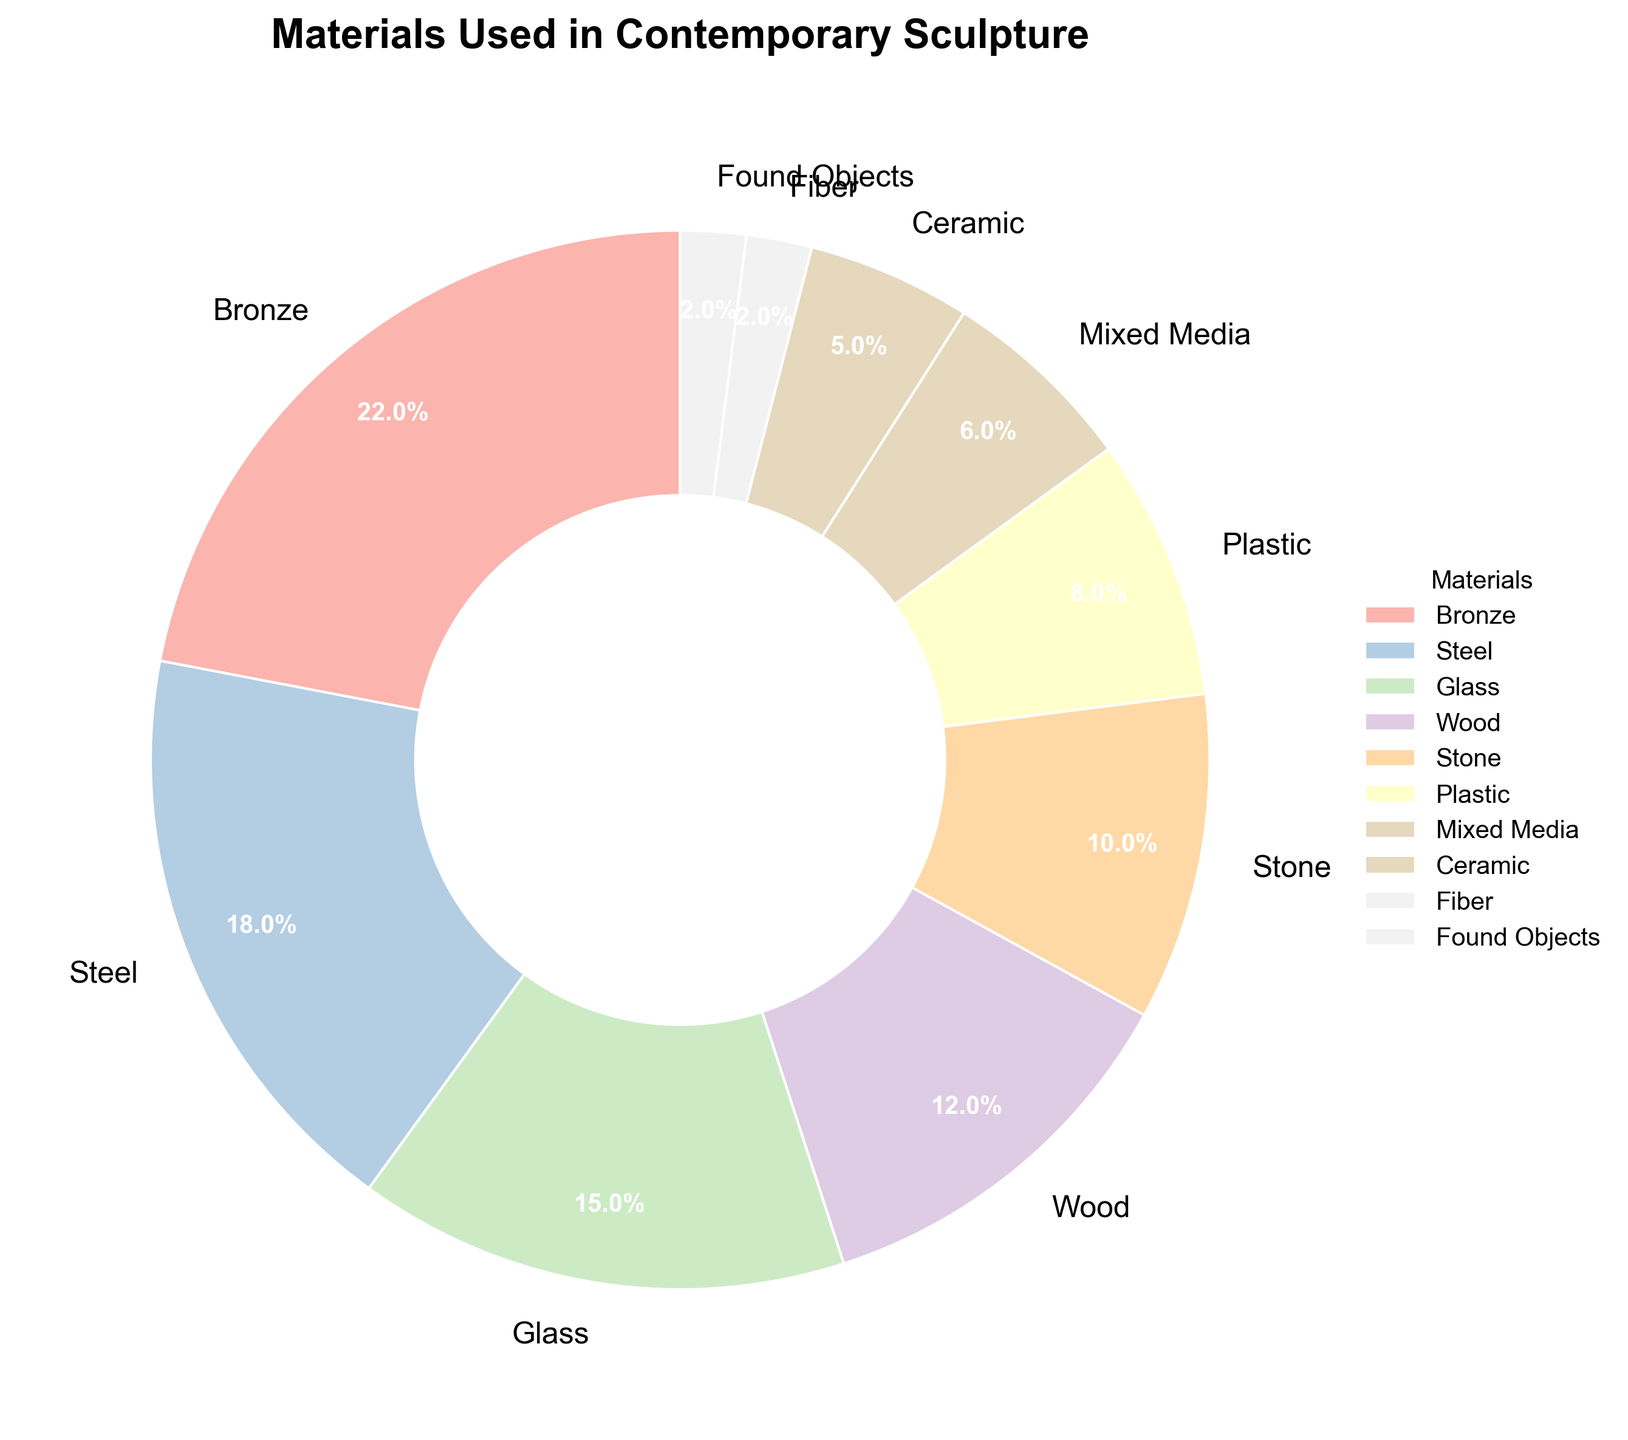Which material is used the most in contemporary sculpture? According to the pie chart, the material with the largest percentage is Bronze at 22%. Therefore, Bronze is used the most.
Answer: Bronze Which material is used the least in contemporary sculpture? The pie chart shows that Fiber and Found Objects are both used at 2%, which is the smallest percentage. Hence, these two materials are used the least.
Answer: Fiber and Found Objects What is the total percentage of sculptures made using Bronze and Steel? The percentage for Bronze is 22% and for Steel is 18%. Adding these together, 22 + 18 = 40. Thus, the total percentage is 40%.
Answer: 40% Are there more sculptures made using Wood or Plastic? The pie chart shows that Wood is used for 12% of sculptures, whereas Plastic is used for 8%. Therefore, more sculptures are made using Wood.
Answer: Wood How much more is the percentage for Steel than the percentage for Ceramic? The percentage for Steel is 18% and for Ceramic is 5%. Subtracting these, 18 - 5 = 13. Thus, the percentage for Steel is 13% higher than for Ceramic.
Answer: 13% What materials together make up 27% of the sculptures? From the pie chart, we see that Glass is 15% and Wood is 12%. Adding these together, 15 + 12 = 27. Hence, Glass and Wood together make up 27% of the sculptures.
Answer: Glass and Wood What is the total percentage for Mixed Media and Found Objects combined? The percentage for Mixed Media is 6% and for Found Objects is 2%. Adding these together, 6 + 2 = 8. Therefore, the total percentage is 8%.
Answer: 8% Which material has nearly half the percentage of the top material? The top material is Bronze at 22%. Half of 22 is 11. The material closest to 11% is Wood at 12%. Therefore, Wood has nearly half the percentage of Bronze.
Answer: Wood Is the percentage for Glass greater than the combined percentage for Fiber and Found Objects? Glass has a percentage of 15%. The combined percentage for Fiber and Found Objects is 2% + 2% = 4%. Since 15% is greater than 4%, the percentage for Glass is indeed greater.
Answer: Yes What is the difference between the percentages of Stone and Ceramic materials? The percentage for Stone is 10% and for Ceramic is 5%. Subtracting these, 10 - 5 = 5. Thus, the difference is 5%.
Answer: 5% 